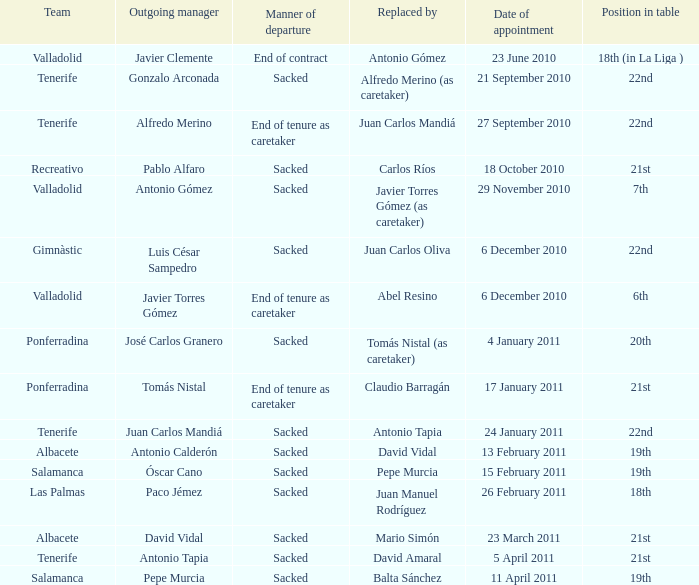What was the appointed position on january 17, 2011? 21st. 